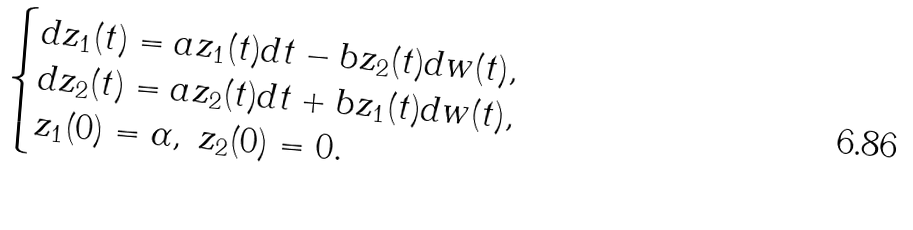Convert formula to latex. <formula><loc_0><loc_0><loc_500><loc_500>\begin{cases} d z _ { 1 } ( t ) = a z _ { 1 } ( t ) d t - b z _ { 2 } ( t ) d w ( t ) , \\ d z _ { 2 } ( t ) = a z _ { 2 } ( t ) d t + b z _ { 1 } ( t ) d w ( t ) , \\ z _ { 1 } ( 0 ) = \alpha , \ z _ { 2 } ( 0 ) = 0 . \end{cases}</formula> 